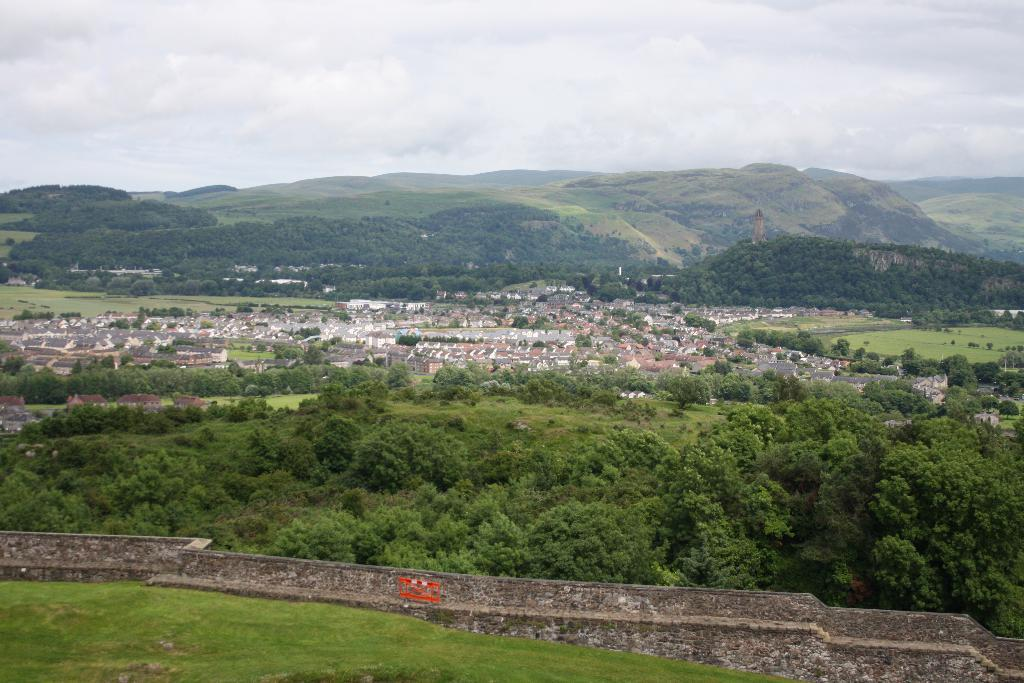What type of structures can be seen in the image? There are houses in the image. What natural elements are present in the image? There are walls, trees, grass, and hills in the image. What is visible in the background of the image? The sky is visible in the background of the image. What can be seen in the sky? Clouds are present in the sky. Can you tell me which expert is standing near the station in the image? There is no expert or station present in the image. What type of ear is visible on the trees in the image? There are no ears present in the image; it features trees, grass, and other natural elements. 